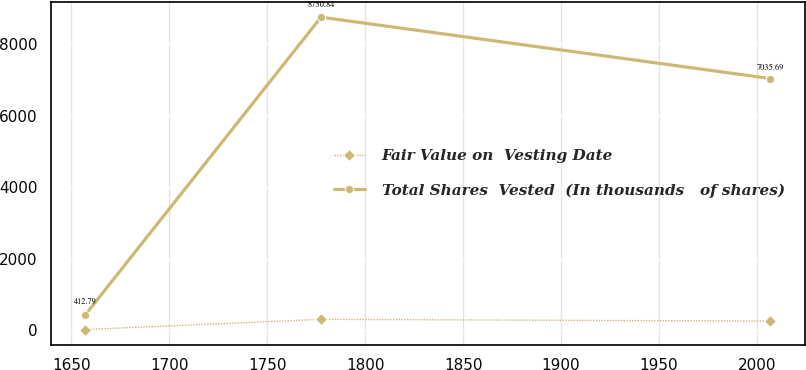Convert chart. <chart><loc_0><loc_0><loc_500><loc_500><line_chart><ecel><fcel>Fair Value on  Vesting Date<fcel>Total Shares  Vested  (In thousands   of shares)<nl><fcel>1656.93<fcel>12.79<fcel>412.79<nl><fcel>1777.43<fcel>298.85<fcel>8750.84<nl><fcel>2006.82<fcel>249.11<fcel>7035.69<nl></chart> 